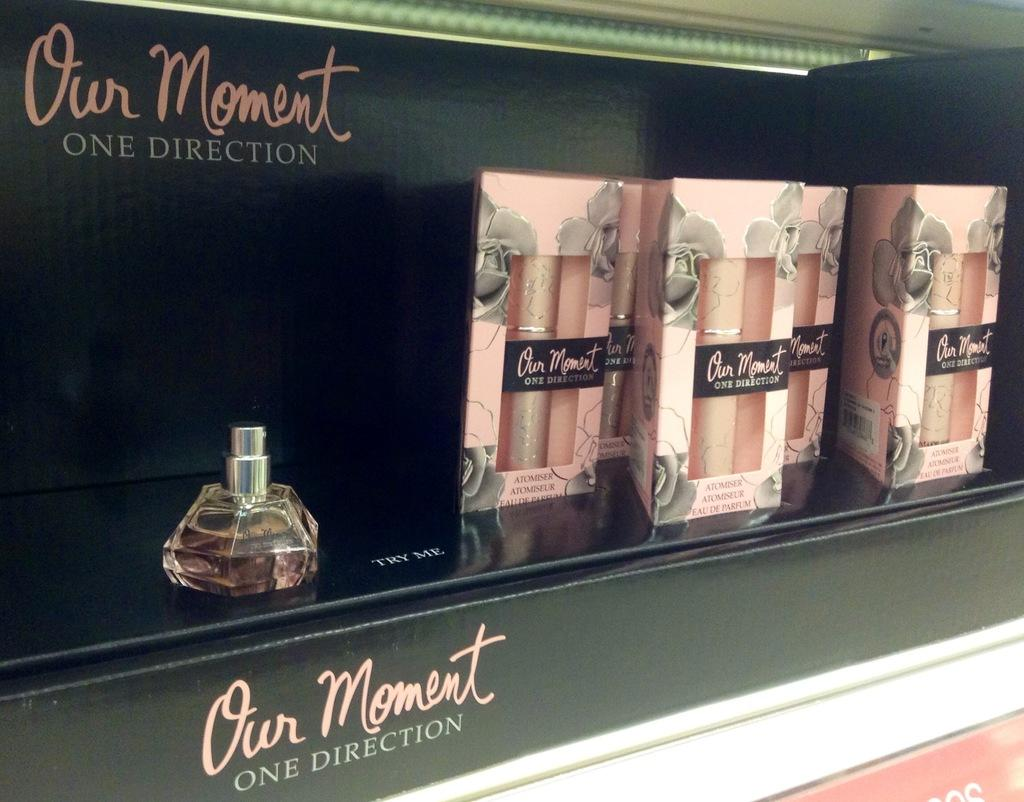Provide a one-sentence caption for the provided image. Our moment One direction perfume in a black case. 